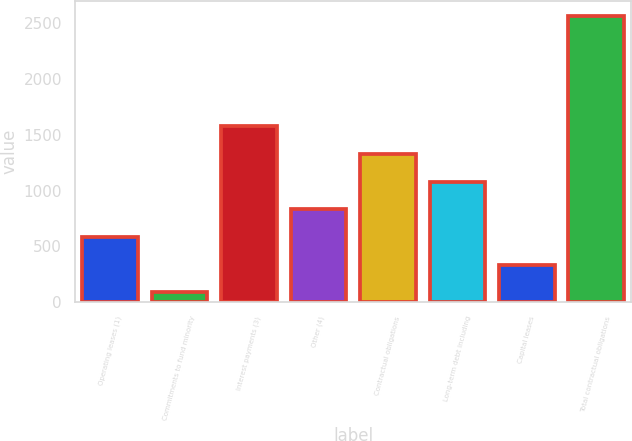Convert chart. <chart><loc_0><loc_0><loc_500><loc_500><bar_chart><fcel>Operating leases (1)<fcel>Commitments to fund minority<fcel>Interest payments (3)<fcel>Other (4)<fcel>Contractual obligations<fcel>Long-term debt including<fcel>Capital leases<fcel>Total contractual obligations<nl><fcel>584.2<fcel>89<fcel>1574.6<fcel>831.8<fcel>1327<fcel>1079.4<fcel>336.6<fcel>2565<nl></chart> 